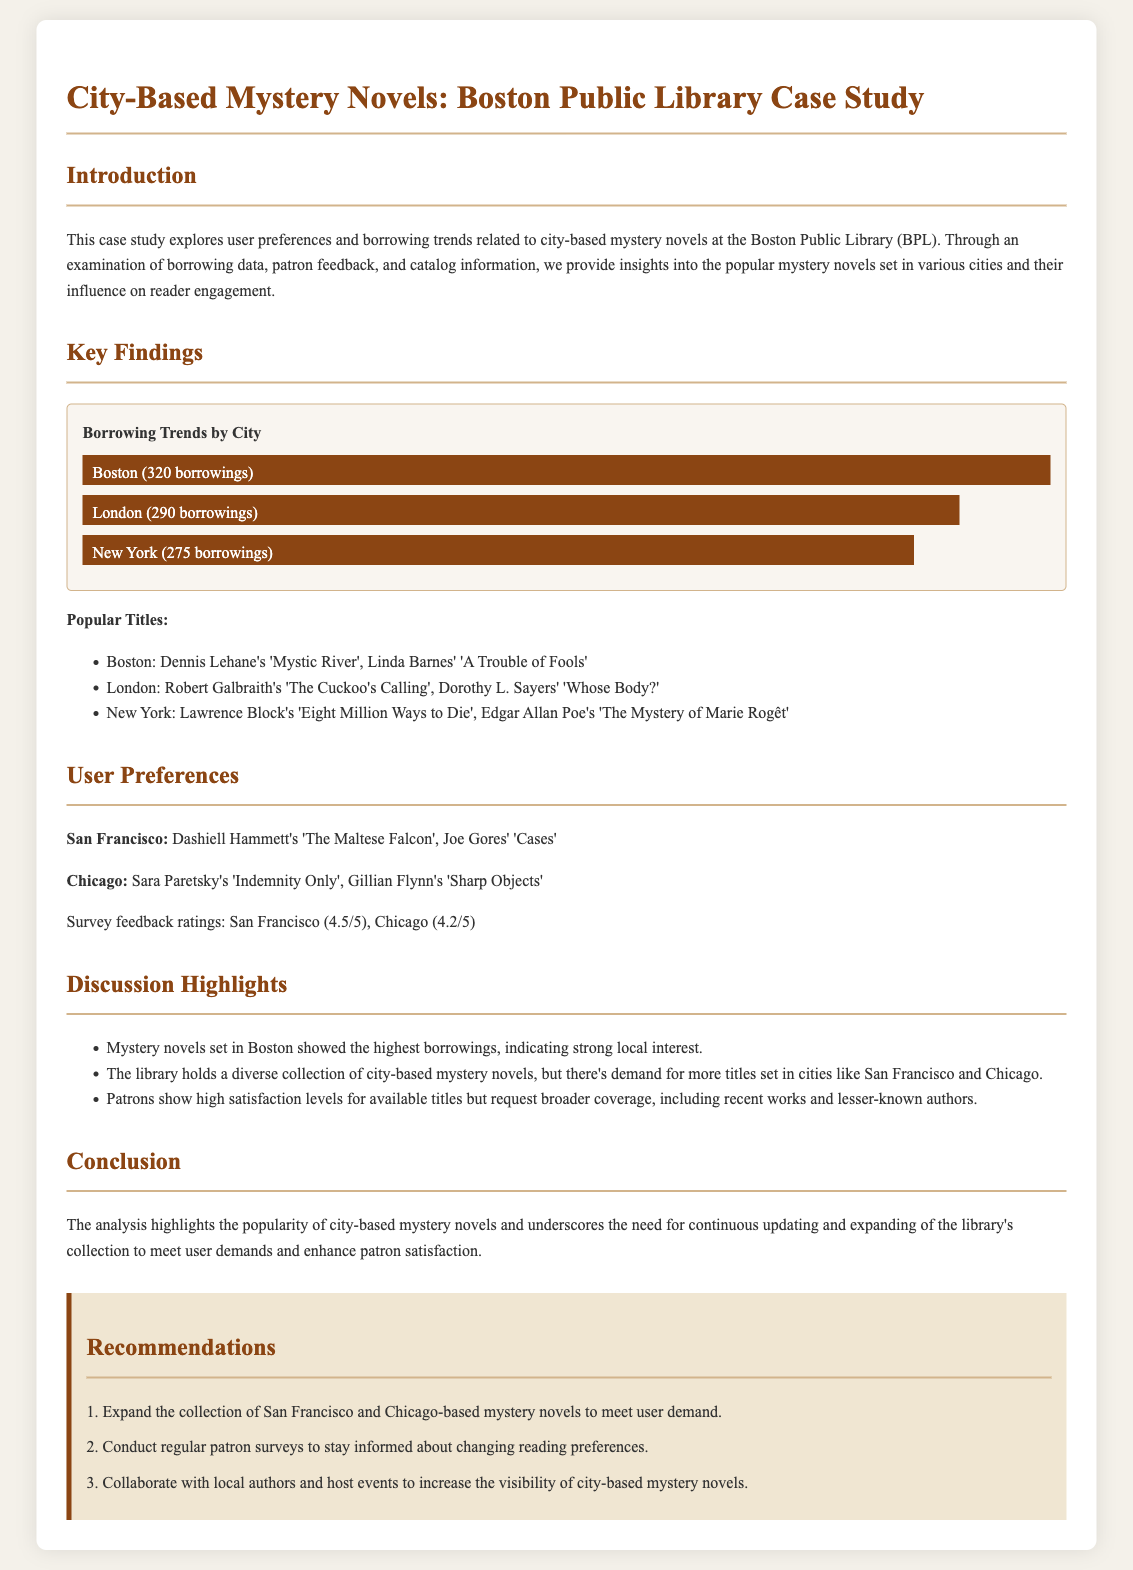What is the title of the case study? The title of the case study is explicitly stated in the document's heading.
Answer: City-Based Mystery Novels: Boston Public Library Case Study How many borrowings were recorded for Boston? The document details the borrowing statistics for various cities, including Boston.
Answer: 320 borrowings Which novel is listed as popular in London? The document provides a list of popular titles for each city, including one for London.
Answer: The Cuckoo's Calling What is the survey feedback rating for San Francisco? The document includes survey feedback ratings for different cities, specifically mentioning San Francisco.
Answer: 4.5/5 Which city-based mystery novel had the lowest borrowings? The chart in the document shows the borrowing trends by city, allowing for comparison.
Answer: New York What recommendation is made about local authors? The recommendations section provides specific suggestions for improving the library’s engagement with patrons.
Answer: Collaborate with local authors How many borrowings were recorded for New York? The document includes specific borrowing statistics for New York in the borrowing trends chart.
Answer: 275 borrowings What are the two cities where user satisfaction ratings were provided? The user preferences section mentions survey feedback ratings for two specific cities.
Answer: San Francisco and Chicago What is a suggested action for the library based on user demand? The document mentions a recommendation based on user demand, focusing on expanding the collection.
Answer: Expand the collection of San Francisco and Chicago-based mystery novels 